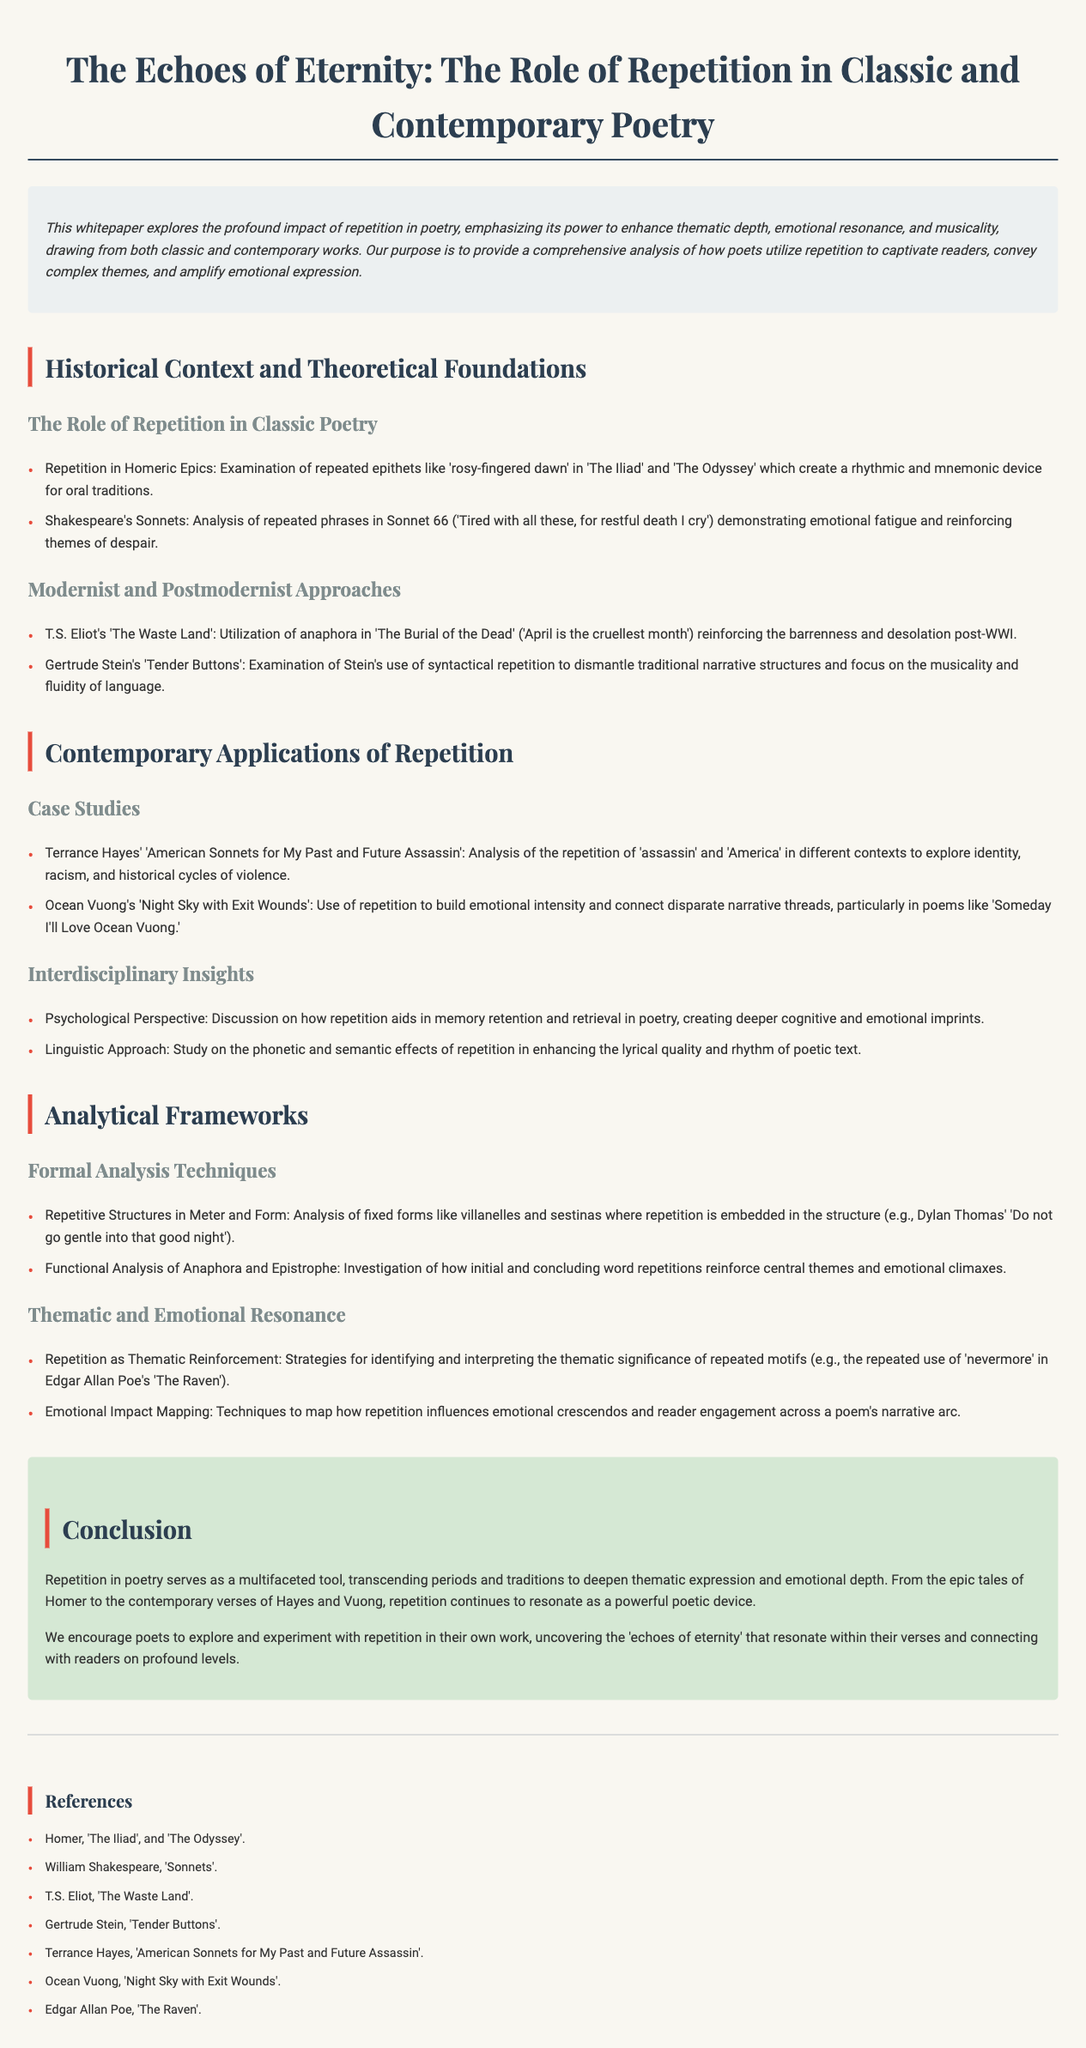What is the title of the whitepaper? The title of the whitepaper is presented at the beginning of the document.
Answer: The Echoes of Eternity: The Role of Repetition in Classic and Contemporary Poetry Who is mentioned in the analysis of repeated phrases in Sonnet 66? The document references a specific author whose work includes Sonnet 66.
Answer: Shakespeare Which poet’s work utilizes anaphora in 'The Burial of the Dead'? This question asks for the poet identified in the modernist approaches section.
Answer: T.S. Eliot What is one technique discussed for mapping emotional impact in poetry? The document highlights a method related to understanding emotional engagement.
Answer: Emotional Impact Mapping How many case studies are mentioned under Contemporary Applications of Repetition? The number of specific case studies outlined in that section of the whitepaper.
Answer: Two What literary form features embedded repetition in the structure, as discussed in the analytical frameworks? The document describes a specific fixed form that utilizes repetition.
Answer: Villanelles What emotional theme is reinforced by the repetition of 'nevermore' in a classic poem? The document outlines a particular repeated motif linked to a central theme in a known poem.
Answer: Thematic Reinforcement How does repetition aid in memory retention according to the psychological perspective? This question addresses the cognitive benefits of repetition mentioned in the document.
Answer: Memory retention and retrieval 